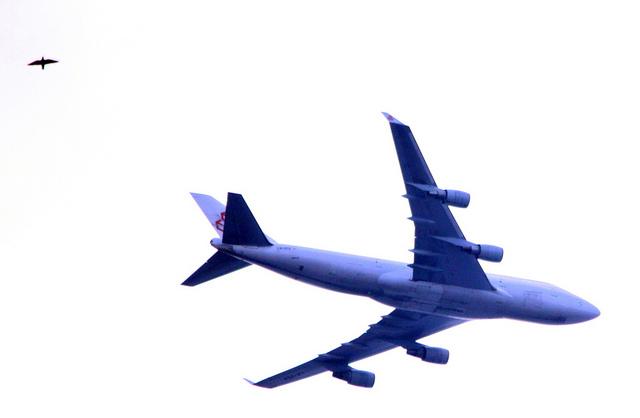Are there any clouds around the plane?
Keep it brief. No. How many engines does the plane have?
Be succinct. 4. Is there a bird in the sky?
Be succinct. Yes. What kind of plane is this?
Short answer required. Jet. What color is the plane?
Write a very short answer. Blue. 